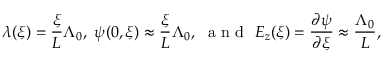Convert formula to latex. <formula><loc_0><loc_0><loc_500><loc_500>\lambda ( \xi ) = \frac { \xi } { L } \Lambda _ { 0 } , \psi ( 0 , \xi ) \approx \frac { \xi } { L } \Lambda _ { 0 } , a n d E _ { z } ( \xi ) = \frac { \partial \psi } { \partial \xi } \approx \frac { \Lambda _ { 0 } } { L } ,</formula> 